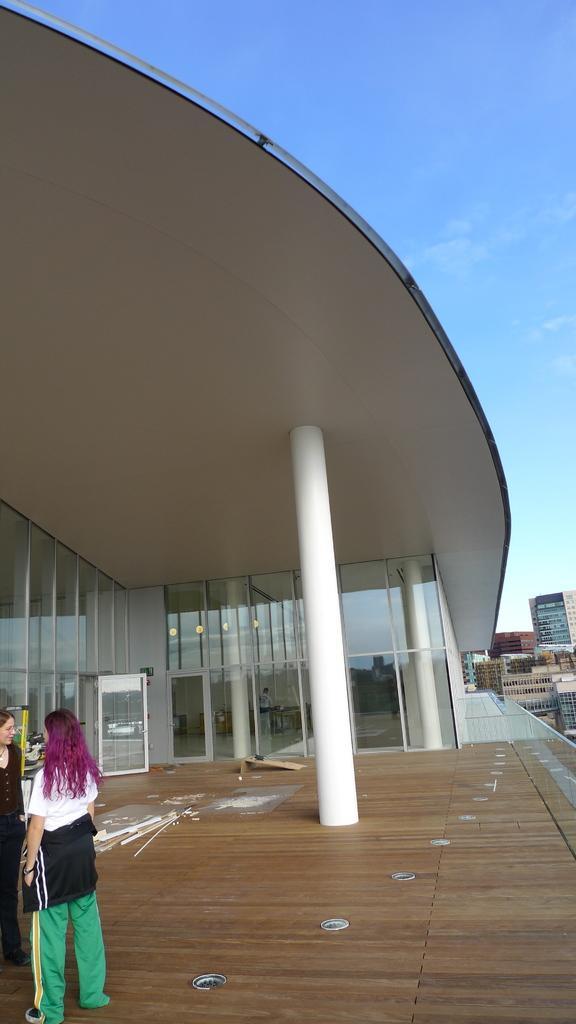How would you summarize this image in a sentence or two? This is an outside view. At the bottom, I can see the floor. On the left side two women are standing. In the middle of the image there is a building along with the pillar and glasses. In the background there are many buildings. At the top of the image I can see the sky in blue color. 